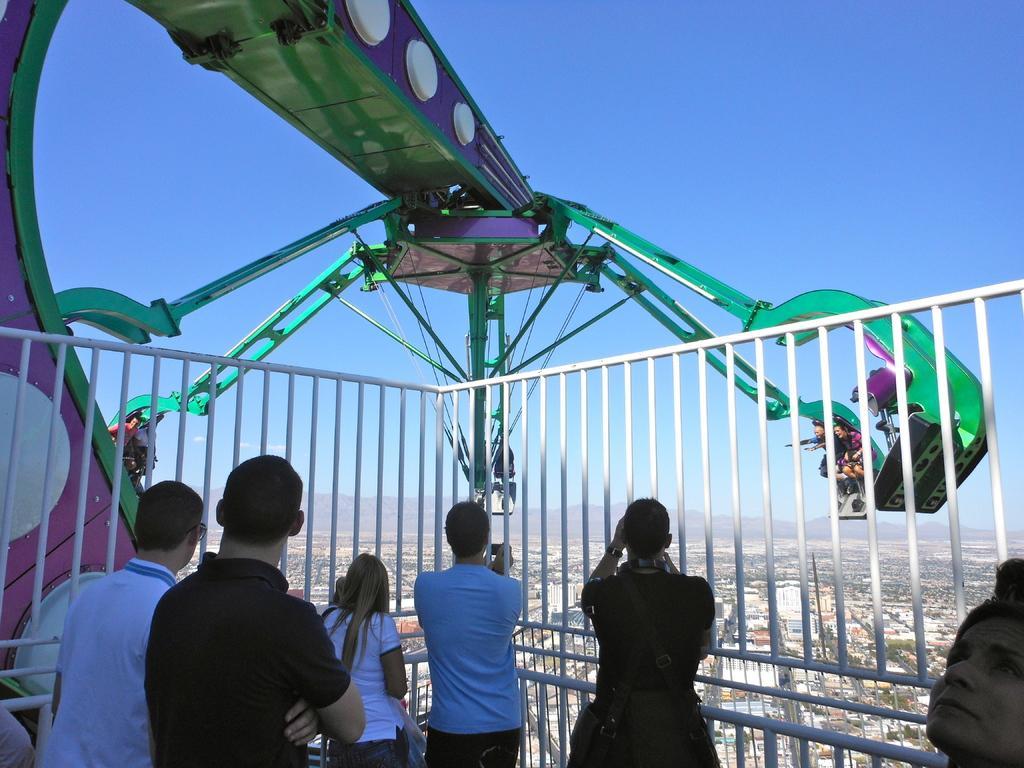In one or two sentences, can you explain what this image depicts? In the picture I can see people are sitting on a green color object. I can see a fence and people are standing among them some are holding objects in hands. In the background I can see buildings and the sky. 